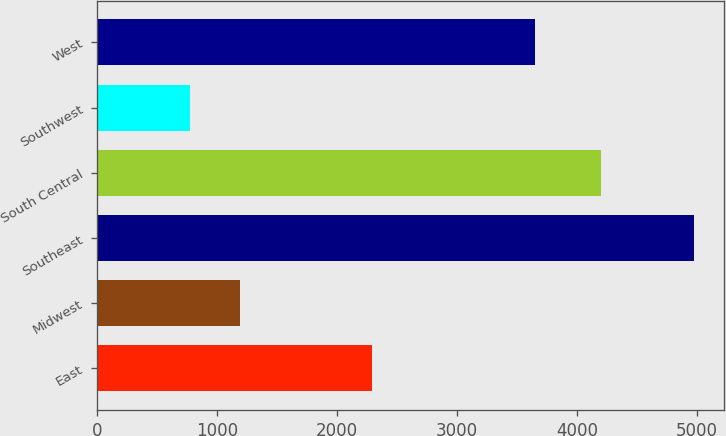Convert chart. <chart><loc_0><loc_0><loc_500><loc_500><bar_chart><fcel>East<fcel>Midwest<fcel>Southeast<fcel>South Central<fcel>Southwest<fcel>West<nl><fcel>2290.2<fcel>1193.12<fcel>4977.8<fcel>4202.4<fcel>772.6<fcel>3650.8<nl></chart> 